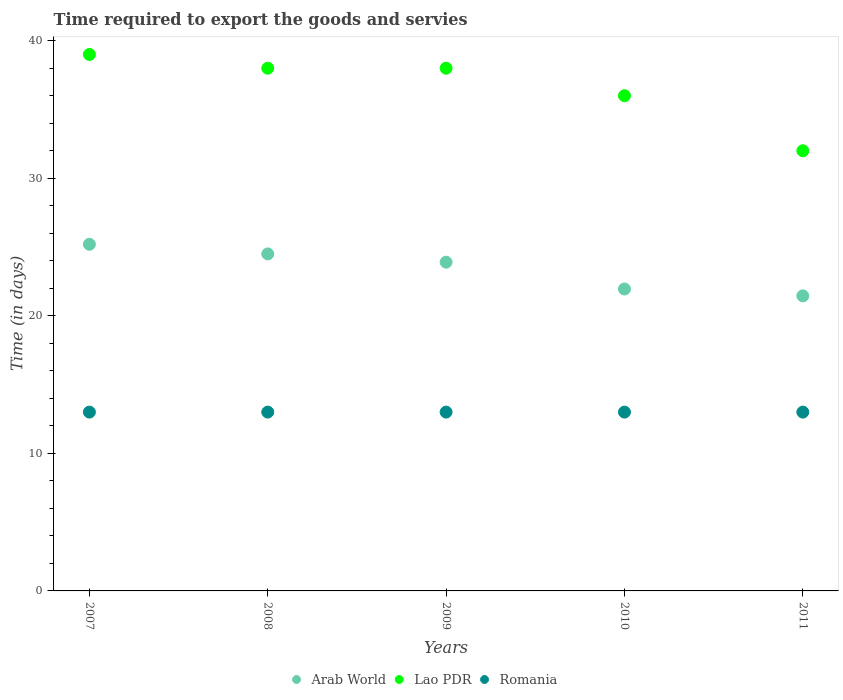What is the number of days required to export the goods and services in Lao PDR in 2008?
Make the answer very short. 38. Across all years, what is the maximum number of days required to export the goods and services in Arab World?
Offer a very short reply. 25.2. Across all years, what is the minimum number of days required to export the goods and services in Arab World?
Offer a very short reply. 21.45. In which year was the number of days required to export the goods and services in Lao PDR maximum?
Make the answer very short. 2007. What is the total number of days required to export the goods and services in Arab World in the graph?
Make the answer very short. 117. What is the difference between the number of days required to export the goods and services in Romania in 2007 and that in 2009?
Offer a very short reply. 0. What is the difference between the number of days required to export the goods and services in Romania in 2011 and the number of days required to export the goods and services in Lao PDR in 2007?
Keep it short and to the point. -26. What is the average number of days required to export the goods and services in Lao PDR per year?
Keep it short and to the point. 36.6. In how many years, is the number of days required to export the goods and services in Romania greater than 16 days?
Keep it short and to the point. 0. What is the ratio of the number of days required to export the goods and services in Lao PDR in 2008 to that in 2010?
Your answer should be compact. 1.06. Is the number of days required to export the goods and services in Romania in 2008 less than that in 2011?
Ensure brevity in your answer.  No. What is the difference between the highest and the second highest number of days required to export the goods and services in Arab World?
Your answer should be very brief. 0.7. What is the difference between the highest and the lowest number of days required to export the goods and services in Arab World?
Keep it short and to the point. 3.75. In how many years, is the number of days required to export the goods and services in Arab World greater than the average number of days required to export the goods and services in Arab World taken over all years?
Offer a terse response. 3. Is the number of days required to export the goods and services in Lao PDR strictly greater than the number of days required to export the goods and services in Arab World over the years?
Your response must be concise. Yes. Is the number of days required to export the goods and services in Lao PDR strictly less than the number of days required to export the goods and services in Arab World over the years?
Keep it short and to the point. No. Are the values on the major ticks of Y-axis written in scientific E-notation?
Provide a succinct answer. No. Does the graph contain grids?
Your response must be concise. No. How many legend labels are there?
Give a very brief answer. 3. What is the title of the graph?
Provide a short and direct response. Time required to export the goods and servies. Does "Least developed countries" appear as one of the legend labels in the graph?
Ensure brevity in your answer.  No. What is the label or title of the Y-axis?
Your answer should be very brief. Time (in days). What is the Time (in days) of Arab World in 2007?
Give a very brief answer. 25.2. What is the Time (in days) of Romania in 2007?
Offer a terse response. 13. What is the Time (in days) in Arab World in 2008?
Provide a short and direct response. 24.5. What is the Time (in days) of Arab World in 2009?
Make the answer very short. 23.9. What is the Time (in days) of Arab World in 2010?
Provide a succinct answer. 21.95. What is the Time (in days) in Lao PDR in 2010?
Your response must be concise. 36. What is the Time (in days) in Arab World in 2011?
Your response must be concise. 21.45. What is the Time (in days) in Lao PDR in 2011?
Make the answer very short. 32. What is the Time (in days) of Romania in 2011?
Provide a succinct answer. 13. Across all years, what is the maximum Time (in days) in Arab World?
Offer a very short reply. 25.2. Across all years, what is the maximum Time (in days) of Lao PDR?
Your answer should be compact. 39. Across all years, what is the maximum Time (in days) in Romania?
Provide a short and direct response. 13. Across all years, what is the minimum Time (in days) in Arab World?
Your answer should be compact. 21.45. Across all years, what is the minimum Time (in days) of Lao PDR?
Your answer should be compact. 32. What is the total Time (in days) of Arab World in the graph?
Provide a succinct answer. 117. What is the total Time (in days) of Lao PDR in the graph?
Your answer should be very brief. 183. What is the total Time (in days) in Romania in the graph?
Provide a succinct answer. 65. What is the difference between the Time (in days) of Lao PDR in 2007 and that in 2008?
Provide a short and direct response. 1. What is the difference between the Time (in days) in Romania in 2007 and that in 2009?
Your answer should be compact. 0. What is the difference between the Time (in days) in Arab World in 2007 and that in 2010?
Your answer should be very brief. 3.25. What is the difference between the Time (in days) of Lao PDR in 2007 and that in 2010?
Provide a short and direct response. 3. What is the difference between the Time (in days) in Romania in 2007 and that in 2010?
Your answer should be very brief. 0. What is the difference between the Time (in days) in Arab World in 2007 and that in 2011?
Make the answer very short. 3.75. What is the difference between the Time (in days) of Lao PDR in 2007 and that in 2011?
Provide a succinct answer. 7. What is the difference between the Time (in days) in Romania in 2007 and that in 2011?
Keep it short and to the point. 0. What is the difference between the Time (in days) in Arab World in 2008 and that in 2009?
Keep it short and to the point. 0.6. What is the difference between the Time (in days) in Romania in 2008 and that in 2009?
Provide a succinct answer. 0. What is the difference between the Time (in days) of Arab World in 2008 and that in 2010?
Your answer should be compact. 2.55. What is the difference between the Time (in days) of Arab World in 2008 and that in 2011?
Provide a short and direct response. 3.05. What is the difference between the Time (in days) in Lao PDR in 2008 and that in 2011?
Keep it short and to the point. 6. What is the difference between the Time (in days) in Arab World in 2009 and that in 2010?
Your response must be concise. 1.95. What is the difference between the Time (in days) of Lao PDR in 2009 and that in 2010?
Your response must be concise. 2. What is the difference between the Time (in days) of Romania in 2009 and that in 2010?
Keep it short and to the point. 0. What is the difference between the Time (in days) in Arab World in 2009 and that in 2011?
Ensure brevity in your answer.  2.45. What is the difference between the Time (in days) in Lao PDR in 2009 and that in 2011?
Keep it short and to the point. 6. What is the difference between the Time (in days) of Arab World in 2010 and that in 2011?
Your response must be concise. 0.5. What is the difference between the Time (in days) in Lao PDR in 2010 and that in 2011?
Your response must be concise. 4. What is the difference between the Time (in days) of Arab World in 2007 and the Time (in days) of Lao PDR in 2008?
Keep it short and to the point. -12.8. What is the difference between the Time (in days) of Arab World in 2007 and the Time (in days) of Romania in 2008?
Keep it short and to the point. 12.2. What is the difference between the Time (in days) of Lao PDR in 2007 and the Time (in days) of Romania in 2009?
Give a very brief answer. 26. What is the difference between the Time (in days) in Arab World in 2008 and the Time (in days) in Lao PDR in 2009?
Provide a succinct answer. -13.5. What is the difference between the Time (in days) of Arab World in 2008 and the Time (in days) of Romania in 2009?
Your response must be concise. 11.5. What is the difference between the Time (in days) of Lao PDR in 2008 and the Time (in days) of Romania in 2011?
Offer a very short reply. 25. What is the difference between the Time (in days) in Arab World in 2009 and the Time (in days) in Romania in 2010?
Give a very brief answer. 10.9. What is the difference between the Time (in days) in Lao PDR in 2009 and the Time (in days) in Romania in 2010?
Ensure brevity in your answer.  25. What is the difference between the Time (in days) in Arab World in 2009 and the Time (in days) in Lao PDR in 2011?
Give a very brief answer. -8.1. What is the difference between the Time (in days) in Arab World in 2009 and the Time (in days) in Romania in 2011?
Keep it short and to the point. 10.9. What is the difference between the Time (in days) in Arab World in 2010 and the Time (in days) in Lao PDR in 2011?
Provide a short and direct response. -10.05. What is the difference between the Time (in days) of Arab World in 2010 and the Time (in days) of Romania in 2011?
Provide a succinct answer. 8.95. What is the difference between the Time (in days) of Lao PDR in 2010 and the Time (in days) of Romania in 2011?
Offer a very short reply. 23. What is the average Time (in days) of Arab World per year?
Your answer should be very brief. 23.4. What is the average Time (in days) in Lao PDR per year?
Make the answer very short. 36.6. In the year 2008, what is the difference between the Time (in days) in Arab World and Time (in days) in Lao PDR?
Offer a very short reply. -13.5. In the year 2008, what is the difference between the Time (in days) of Arab World and Time (in days) of Romania?
Offer a very short reply. 11.5. In the year 2009, what is the difference between the Time (in days) in Arab World and Time (in days) in Lao PDR?
Make the answer very short. -14.1. In the year 2009, what is the difference between the Time (in days) of Arab World and Time (in days) of Romania?
Provide a short and direct response. 10.9. In the year 2010, what is the difference between the Time (in days) of Arab World and Time (in days) of Lao PDR?
Provide a succinct answer. -14.05. In the year 2010, what is the difference between the Time (in days) of Arab World and Time (in days) of Romania?
Keep it short and to the point. 8.95. In the year 2011, what is the difference between the Time (in days) in Arab World and Time (in days) in Lao PDR?
Provide a succinct answer. -10.55. In the year 2011, what is the difference between the Time (in days) in Arab World and Time (in days) in Romania?
Provide a succinct answer. 8.45. What is the ratio of the Time (in days) in Arab World in 2007 to that in 2008?
Keep it short and to the point. 1.03. What is the ratio of the Time (in days) of Lao PDR in 2007 to that in 2008?
Offer a very short reply. 1.03. What is the ratio of the Time (in days) in Arab World in 2007 to that in 2009?
Give a very brief answer. 1.05. What is the ratio of the Time (in days) of Lao PDR in 2007 to that in 2009?
Provide a succinct answer. 1.03. What is the ratio of the Time (in days) of Romania in 2007 to that in 2009?
Your response must be concise. 1. What is the ratio of the Time (in days) in Arab World in 2007 to that in 2010?
Offer a very short reply. 1.15. What is the ratio of the Time (in days) in Romania in 2007 to that in 2010?
Your response must be concise. 1. What is the ratio of the Time (in days) in Arab World in 2007 to that in 2011?
Offer a very short reply. 1.17. What is the ratio of the Time (in days) of Lao PDR in 2007 to that in 2011?
Your response must be concise. 1.22. What is the ratio of the Time (in days) in Arab World in 2008 to that in 2009?
Provide a short and direct response. 1.03. What is the ratio of the Time (in days) in Romania in 2008 to that in 2009?
Provide a short and direct response. 1. What is the ratio of the Time (in days) of Arab World in 2008 to that in 2010?
Provide a short and direct response. 1.12. What is the ratio of the Time (in days) in Lao PDR in 2008 to that in 2010?
Ensure brevity in your answer.  1.06. What is the ratio of the Time (in days) in Arab World in 2008 to that in 2011?
Offer a very short reply. 1.14. What is the ratio of the Time (in days) in Lao PDR in 2008 to that in 2011?
Your response must be concise. 1.19. What is the ratio of the Time (in days) of Arab World in 2009 to that in 2010?
Provide a succinct answer. 1.09. What is the ratio of the Time (in days) of Lao PDR in 2009 to that in 2010?
Your answer should be compact. 1.06. What is the ratio of the Time (in days) in Arab World in 2009 to that in 2011?
Your response must be concise. 1.11. What is the ratio of the Time (in days) in Lao PDR in 2009 to that in 2011?
Offer a terse response. 1.19. What is the ratio of the Time (in days) of Arab World in 2010 to that in 2011?
Give a very brief answer. 1.02. What is the ratio of the Time (in days) in Lao PDR in 2010 to that in 2011?
Your answer should be very brief. 1.12. What is the difference between the highest and the second highest Time (in days) in Lao PDR?
Offer a terse response. 1. What is the difference between the highest and the lowest Time (in days) in Arab World?
Your response must be concise. 3.75. What is the difference between the highest and the lowest Time (in days) of Romania?
Your response must be concise. 0. 